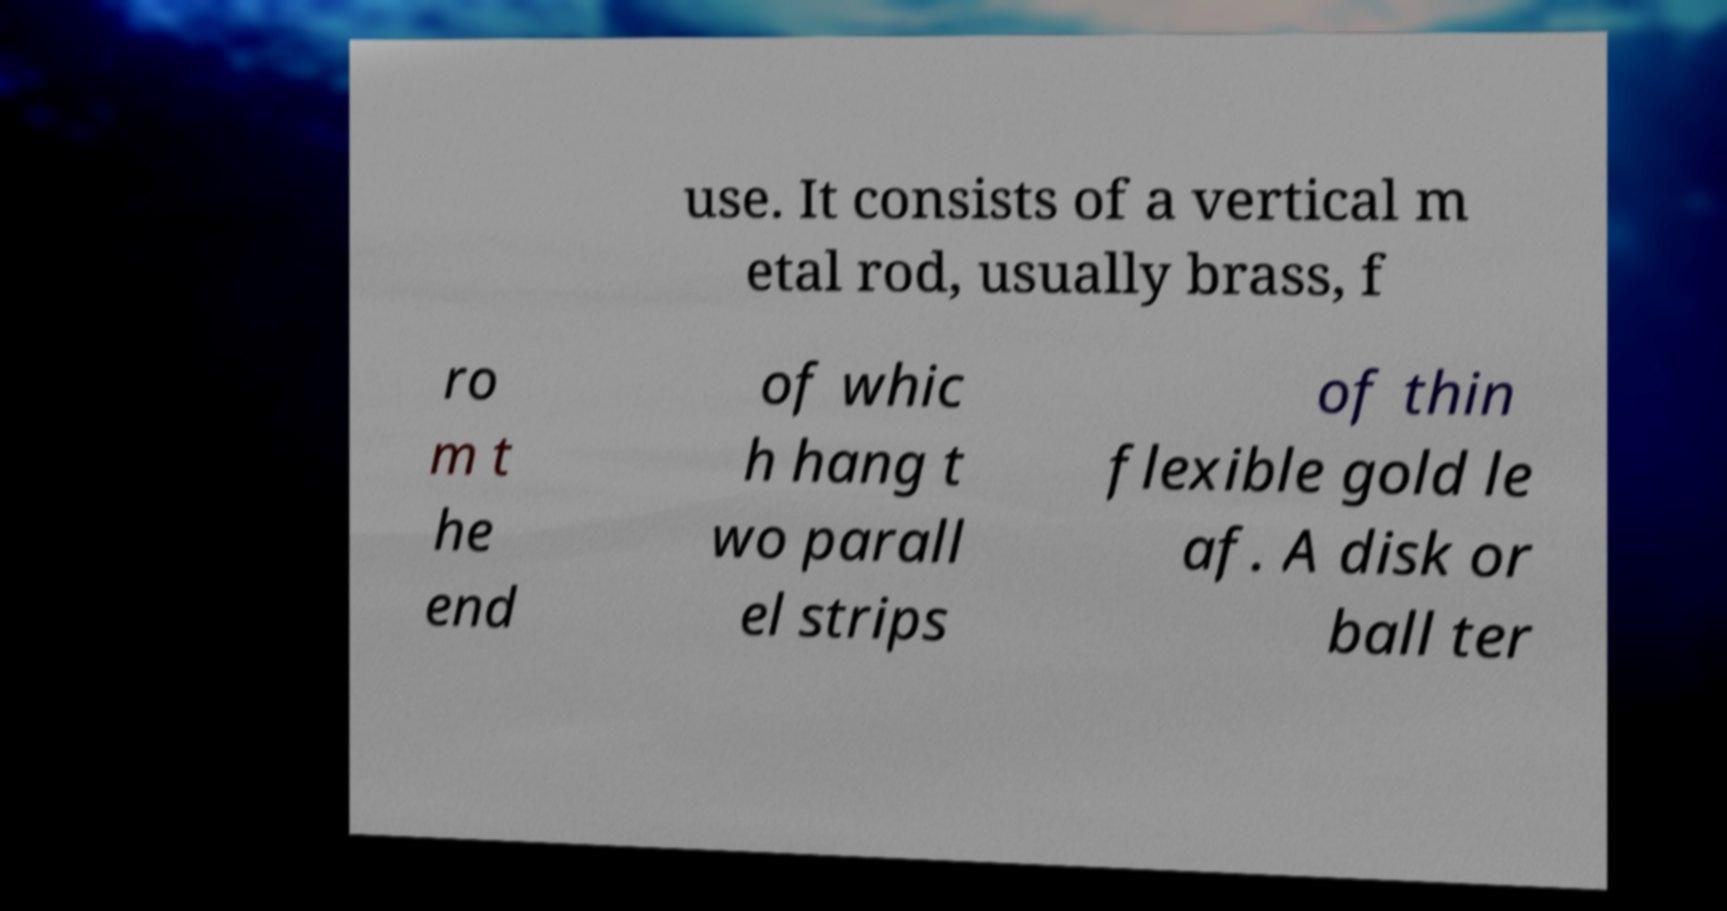Could you assist in decoding the text presented in this image and type it out clearly? use. It consists of a vertical m etal rod, usually brass, f ro m t he end of whic h hang t wo parall el strips of thin flexible gold le af. A disk or ball ter 